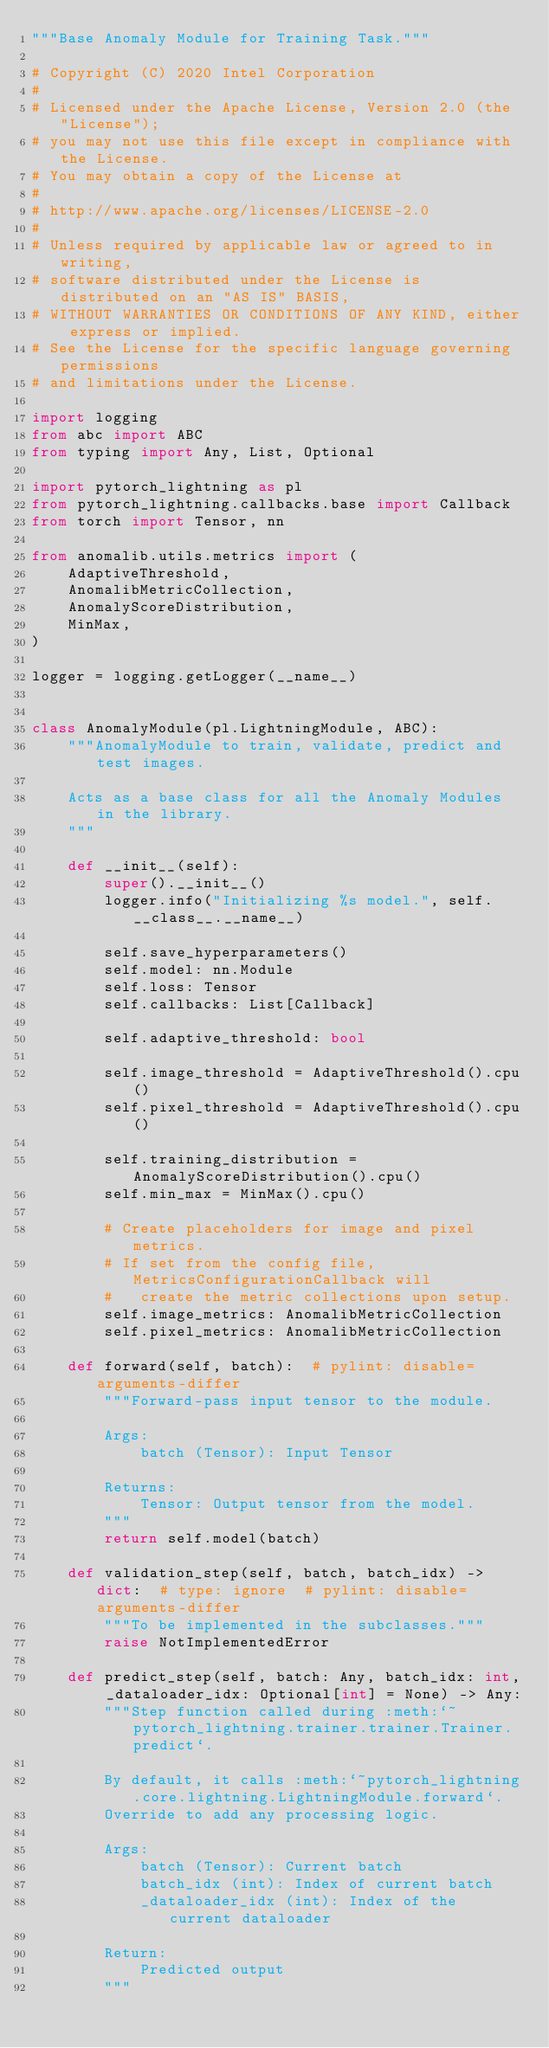<code> <loc_0><loc_0><loc_500><loc_500><_Python_>"""Base Anomaly Module for Training Task."""

# Copyright (C) 2020 Intel Corporation
#
# Licensed under the Apache License, Version 2.0 (the "License");
# you may not use this file except in compliance with the License.
# You may obtain a copy of the License at
#
# http://www.apache.org/licenses/LICENSE-2.0
#
# Unless required by applicable law or agreed to in writing,
# software distributed under the License is distributed on an "AS IS" BASIS,
# WITHOUT WARRANTIES OR CONDITIONS OF ANY KIND, either express or implied.
# See the License for the specific language governing permissions
# and limitations under the License.

import logging
from abc import ABC
from typing import Any, List, Optional

import pytorch_lightning as pl
from pytorch_lightning.callbacks.base import Callback
from torch import Tensor, nn

from anomalib.utils.metrics import (
    AdaptiveThreshold,
    AnomalibMetricCollection,
    AnomalyScoreDistribution,
    MinMax,
)

logger = logging.getLogger(__name__)


class AnomalyModule(pl.LightningModule, ABC):
    """AnomalyModule to train, validate, predict and test images.

    Acts as a base class for all the Anomaly Modules in the library.
    """

    def __init__(self):
        super().__init__()
        logger.info("Initializing %s model.", self.__class__.__name__)

        self.save_hyperparameters()
        self.model: nn.Module
        self.loss: Tensor
        self.callbacks: List[Callback]

        self.adaptive_threshold: bool

        self.image_threshold = AdaptiveThreshold().cpu()
        self.pixel_threshold = AdaptiveThreshold().cpu()

        self.training_distribution = AnomalyScoreDistribution().cpu()
        self.min_max = MinMax().cpu()

        # Create placeholders for image and pixel metrics.
        # If set from the config file, MetricsConfigurationCallback will
        #   create the metric collections upon setup.
        self.image_metrics: AnomalibMetricCollection
        self.pixel_metrics: AnomalibMetricCollection

    def forward(self, batch):  # pylint: disable=arguments-differ
        """Forward-pass input tensor to the module.

        Args:
            batch (Tensor): Input Tensor

        Returns:
            Tensor: Output tensor from the model.
        """
        return self.model(batch)

    def validation_step(self, batch, batch_idx) -> dict:  # type: ignore  # pylint: disable=arguments-differ
        """To be implemented in the subclasses."""
        raise NotImplementedError

    def predict_step(self, batch: Any, batch_idx: int, _dataloader_idx: Optional[int] = None) -> Any:
        """Step function called during :meth:`~pytorch_lightning.trainer.trainer.Trainer.predict`.

        By default, it calls :meth:`~pytorch_lightning.core.lightning.LightningModule.forward`.
        Override to add any processing logic.

        Args:
            batch (Tensor): Current batch
            batch_idx (int): Index of current batch
            _dataloader_idx (int): Index of the current dataloader

        Return:
            Predicted output
        """</code> 